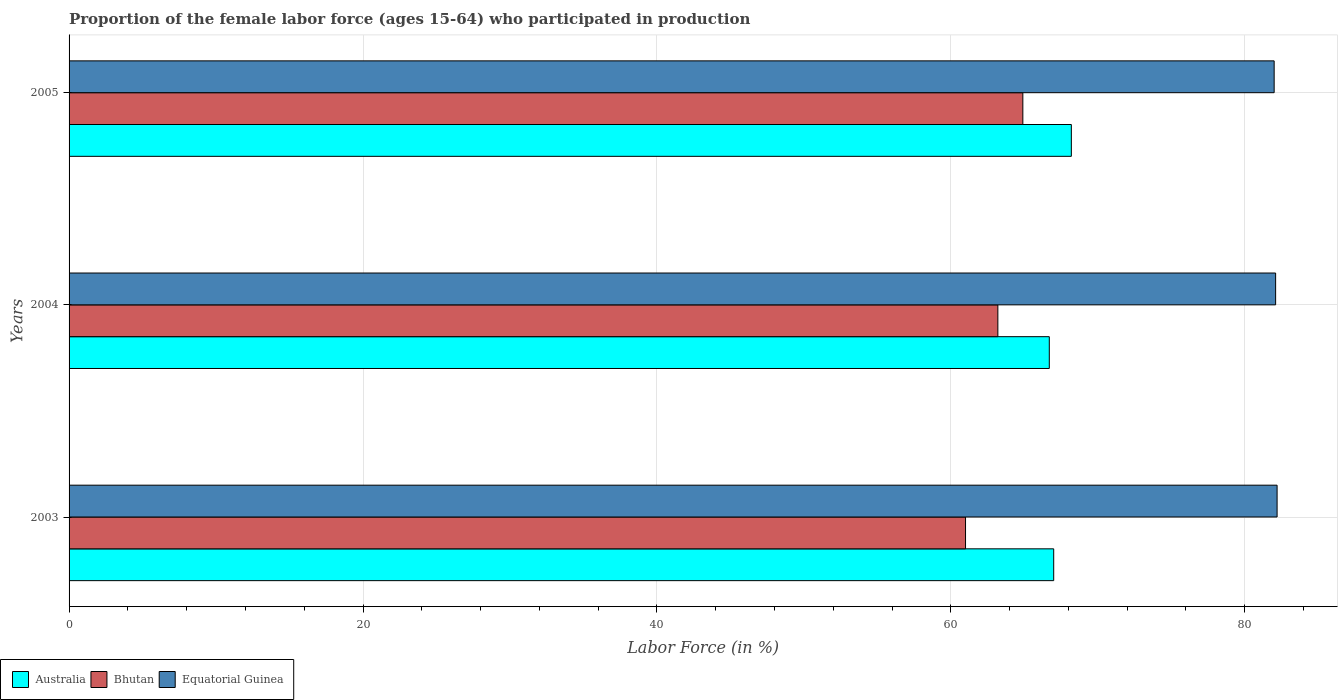How many different coloured bars are there?
Your answer should be very brief. 3. Are the number of bars per tick equal to the number of legend labels?
Ensure brevity in your answer.  Yes. Are the number of bars on each tick of the Y-axis equal?
Provide a short and direct response. Yes. How many bars are there on the 1st tick from the top?
Your response must be concise. 3. How many bars are there on the 3rd tick from the bottom?
Give a very brief answer. 3. What is the proportion of the female labor force who participated in production in Equatorial Guinea in 2003?
Offer a very short reply. 82.2. Across all years, what is the maximum proportion of the female labor force who participated in production in Australia?
Give a very brief answer. 68.2. Across all years, what is the minimum proportion of the female labor force who participated in production in Bhutan?
Provide a short and direct response. 61. In which year was the proportion of the female labor force who participated in production in Bhutan maximum?
Provide a short and direct response. 2005. In which year was the proportion of the female labor force who participated in production in Bhutan minimum?
Offer a terse response. 2003. What is the total proportion of the female labor force who participated in production in Australia in the graph?
Offer a terse response. 201.9. What is the difference between the proportion of the female labor force who participated in production in Equatorial Guinea in 2003 and that in 2004?
Offer a terse response. 0.1. What is the difference between the proportion of the female labor force who participated in production in Equatorial Guinea in 2004 and the proportion of the female labor force who participated in production in Bhutan in 2003?
Provide a succinct answer. 21.1. What is the average proportion of the female labor force who participated in production in Equatorial Guinea per year?
Provide a succinct answer. 82.1. In the year 2005, what is the difference between the proportion of the female labor force who participated in production in Bhutan and proportion of the female labor force who participated in production in Australia?
Make the answer very short. -3.3. What is the ratio of the proportion of the female labor force who participated in production in Australia in 2004 to that in 2005?
Provide a succinct answer. 0.98. What is the difference between the highest and the second highest proportion of the female labor force who participated in production in Equatorial Guinea?
Your answer should be very brief. 0.1. What is the difference between the highest and the lowest proportion of the female labor force who participated in production in Equatorial Guinea?
Keep it short and to the point. 0.2. In how many years, is the proportion of the female labor force who participated in production in Equatorial Guinea greater than the average proportion of the female labor force who participated in production in Equatorial Guinea taken over all years?
Give a very brief answer. 1. Is the sum of the proportion of the female labor force who participated in production in Australia in 2003 and 2005 greater than the maximum proportion of the female labor force who participated in production in Bhutan across all years?
Provide a short and direct response. Yes. What does the 2nd bar from the top in 2003 represents?
Offer a terse response. Bhutan. What does the 3rd bar from the bottom in 2004 represents?
Offer a very short reply. Equatorial Guinea. Are all the bars in the graph horizontal?
Your answer should be very brief. Yes. Are the values on the major ticks of X-axis written in scientific E-notation?
Offer a terse response. No. Does the graph contain any zero values?
Offer a very short reply. No. Does the graph contain grids?
Offer a very short reply. Yes. How many legend labels are there?
Give a very brief answer. 3. How are the legend labels stacked?
Provide a short and direct response. Horizontal. What is the title of the graph?
Your answer should be very brief. Proportion of the female labor force (ages 15-64) who participated in production. Does "United Arab Emirates" appear as one of the legend labels in the graph?
Provide a succinct answer. No. What is the label or title of the Y-axis?
Your answer should be compact. Years. What is the Labor Force (in %) of Australia in 2003?
Your answer should be compact. 67. What is the Labor Force (in %) in Equatorial Guinea in 2003?
Provide a short and direct response. 82.2. What is the Labor Force (in %) in Australia in 2004?
Provide a short and direct response. 66.7. What is the Labor Force (in %) in Bhutan in 2004?
Give a very brief answer. 63.2. What is the Labor Force (in %) of Equatorial Guinea in 2004?
Provide a succinct answer. 82.1. What is the Labor Force (in %) in Australia in 2005?
Offer a terse response. 68.2. What is the Labor Force (in %) of Bhutan in 2005?
Your answer should be very brief. 64.9. Across all years, what is the maximum Labor Force (in %) in Australia?
Offer a terse response. 68.2. Across all years, what is the maximum Labor Force (in %) of Bhutan?
Offer a terse response. 64.9. Across all years, what is the maximum Labor Force (in %) of Equatorial Guinea?
Give a very brief answer. 82.2. Across all years, what is the minimum Labor Force (in %) in Australia?
Ensure brevity in your answer.  66.7. Across all years, what is the minimum Labor Force (in %) in Equatorial Guinea?
Offer a terse response. 82. What is the total Labor Force (in %) of Australia in the graph?
Your response must be concise. 201.9. What is the total Labor Force (in %) of Bhutan in the graph?
Your response must be concise. 189.1. What is the total Labor Force (in %) of Equatorial Guinea in the graph?
Provide a short and direct response. 246.3. What is the difference between the Labor Force (in %) in Australia in 2003 and that in 2004?
Your response must be concise. 0.3. What is the difference between the Labor Force (in %) in Equatorial Guinea in 2003 and that in 2004?
Provide a succinct answer. 0.1. What is the difference between the Labor Force (in %) in Australia in 2003 and that in 2005?
Give a very brief answer. -1.2. What is the difference between the Labor Force (in %) in Bhutan in 2003 and that in 2005?
Your answer should be very brief. -3.9. What is the difference between the Labor Force (in %) in Equatorial Guinea in 2003 and that in 2005?
Offer a terse response. 0.2. What is the difference between the Labor Force (in %) of Australia in 2004 and that in 2005?
Your answer should be very brief. -1.5. What is the difference between the Labor Force (in %) of Australia in 2003 and the Labor Force (in %) of Equatorial Guinea in 2004?
Give a very brief answer. -15.1. What is the difference between the Labor Force (in %) in Bhutan in 2003 and the Labor Force (in %) in Equatorial Guinea in 2004?
Your answer should be compact. -21.1. What is the difference between the Labor Force (in %) in Bhutan in 2003 and the Labor Force (in %) in Equatorial Guinea in 2005?
Give a very brief answer. -21. What is the difference between the Labor Force (in %) in Australia in 2004 and the Labor Force (in %) in Bhutan in 2005?
Provide a succinct answer. 1.8. What is the difference between the Labor Force (in %) of Australia in 2004 and the Labor Force (in %) of Equatorial Guinea in 2005?
Ensure brevity in your answer.  -15.3. What is the difference between the Labor Force (in %) of Bhutan in 2004 and the Labor Force (in %) of Equatorial Guinea in 2005?
Provide a short and direct response. -18.8. What is the average Labor Force (in %) in Australia per year?
Provide a succinct answer. 67.3. What is the average Labor Force (in %) of Bhutan per year?
Your response must be concise. 63.03. What is the average Labor Force (in %) in Equatorial Guinea per year?
Provide a short and direct response. 82.1. In the year 2003, what is the difference between the Labor Force (in %) of Australia and Labor Force (in %) of Equatorial Guinea?
Keep it short and to the point. -15.2. In the year 2003, what is the difference between the Labor Force (in %) of Bhutan and Labor Force (in %) of Equatorial Guinea?
Ensure brevity in your answer.  -21.2. In the year 2004, what is the difference between the Labor Force (in %) in Australia and Labor Force (in %) in Bhutan?
Ensure brevity in your answer.  3.5. In the year 2004, what is the difference between the Labor Force (in %) of Australia and Labor Force (in %) of Equatorial Guinea?
Ensure brevity in your answer.  -15.4. In the year 2004, what is the difference between the Labor Force (in %) in Bhutan and Labor Force (in %) in Equatorial Guinea?
Give a very brief answer. -18.9. In the year 2005, what is the difference between the Labor Force (in %) in Australia and Labor Force (in %) in Bhutan?
Make the answer very short. 3.3. In the year 2005, what is the difference between the Labor Force (in %) of Bhutan and Labor Force (in %) of Equatorial Guinea?
Make the answer very short. -17.1. What is the ratio of the Labor Force (in %) in Australia in 2003 to that in 2004?
Provide a succinct answer. 1. What is the ratio of the Labor Force (in %) in Bhutan in 2003 to that in 2004?
Your answer should be compact. 0.97. What is the ratio of the Labor Force (in %) of Equatorial Guinea in 2003 to that in 2004?
Give a very brief answer. 1. What is the ratio of the Labor Force (in %) of Australia in 2003 to that in 2005?
Give a very brief answer. 0.98. What is the ratio of the Labor Force (in %) of Bhutan in 2003 to that in 2005?
Keep it short and to the point. 0.94. What is the ratio of the Labor Force (in %) in Bhutan in 2004 to that in 2005?
Offer a terse response. 0.97. What is the ratio of the Labor Force (in %) of Equatorial Guinea in 2004 to that in 2005?
Keep it short and to the point. 1. What is the difference between the highest and the second highest Labor Force (in %) in Bhutan?
Make the answer very short. 1.7. What is the difference between the highest and the second highest Labor Force (in %) of Equatorial Guinea?
Provide a succinct answer. 0.1. What is the difference between the highest and the lowest Labor Force (in %) of Australia?
Ensure brevity in your answer.  1.5. What is the difference between the highest and the lowest Labor Force (in %) in Bhutan?
Offer a terse response. 3.9. 